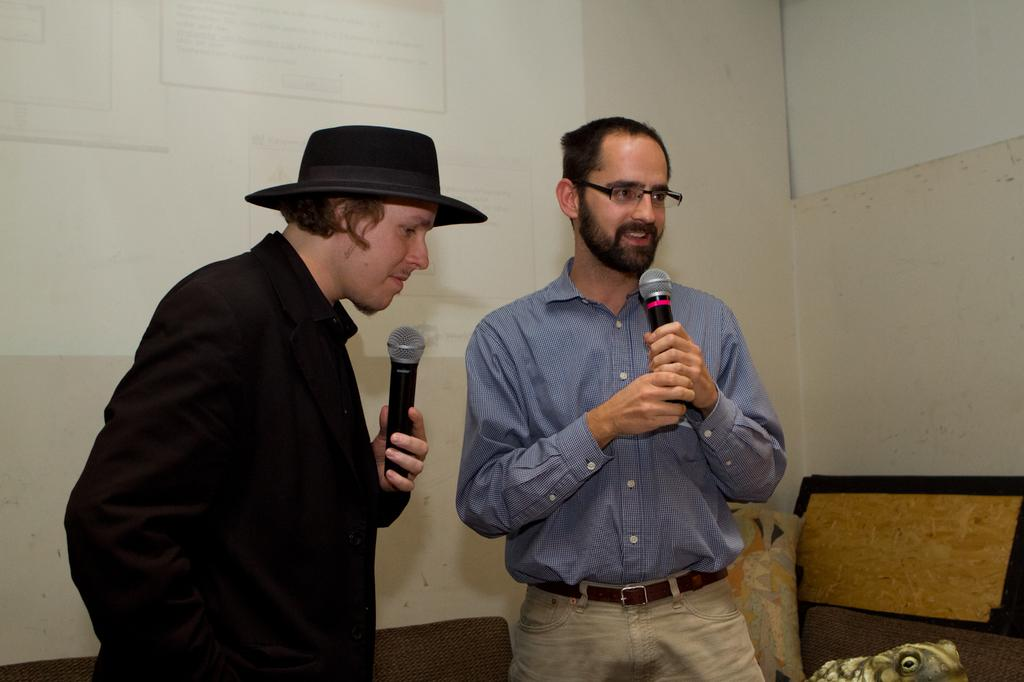How many people are in the image? There are two men in the image. What are the men holding in the image? Both men are holding microphones. Can you describe the action of one of the men in the image? One person is talking. What can be seen in the background of the image? There is a wall and a frog in the background of the image. What type of beast can be seen in the image? There is no beast present in the image. What metal object is being used by the men in the image? The men are holding microphones, but there is no metal object mentioned in the provided facts. 